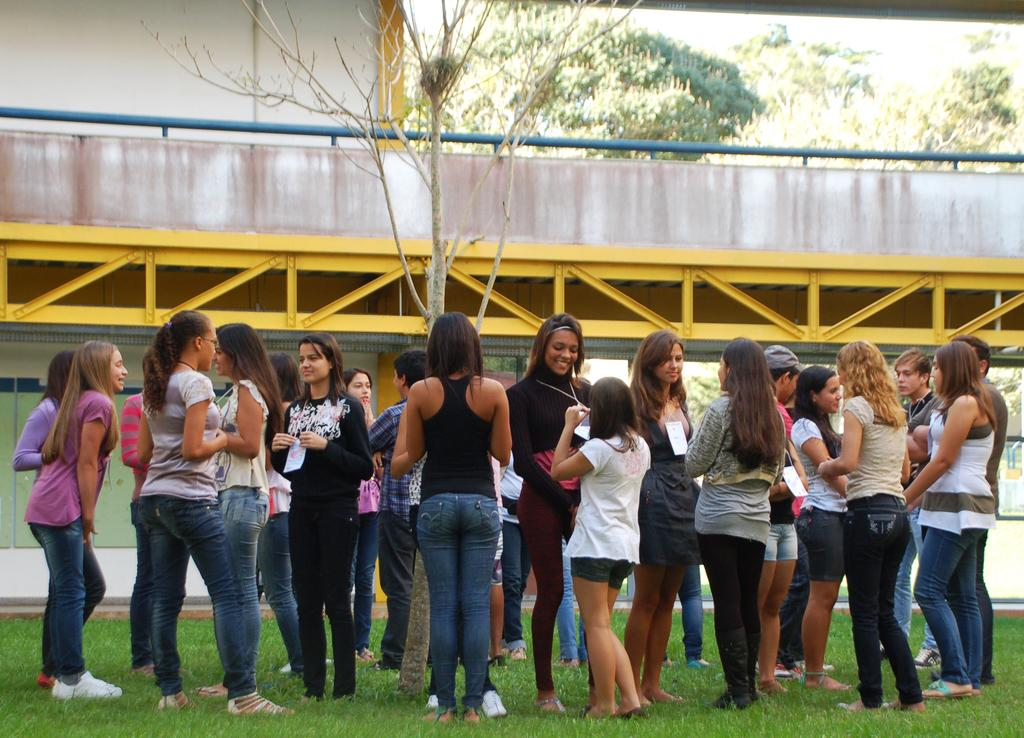What is the surface on which the girls are standing in the image? The girls are standing on the grassland in the image. What structure can be seen behind the grassland? There is a bridge behind the grassland in the image. What type of vegetation is visible in the background? Trees are present in the background of the image. How many cents are scattered on the grassland in the image? There are no cents visible on the grassland in the image. What type of ray is flying above the girls in the image? There are no rays visible in the image; it only features girls standing on the grassland, a bridge, and trees in the background. 